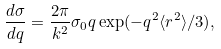Convert formula to latex. <formula><loc_0><loc_0><loc_500><loc_500>\frac { d \sigma } { d q } = \frac { 2 \pi } { k ^ { 2 } } \sigma _ { 0 } q \exp ( - q ^ { 2 } \langle r ^ { 2 } \rangle / 3 ) ,</formula> 